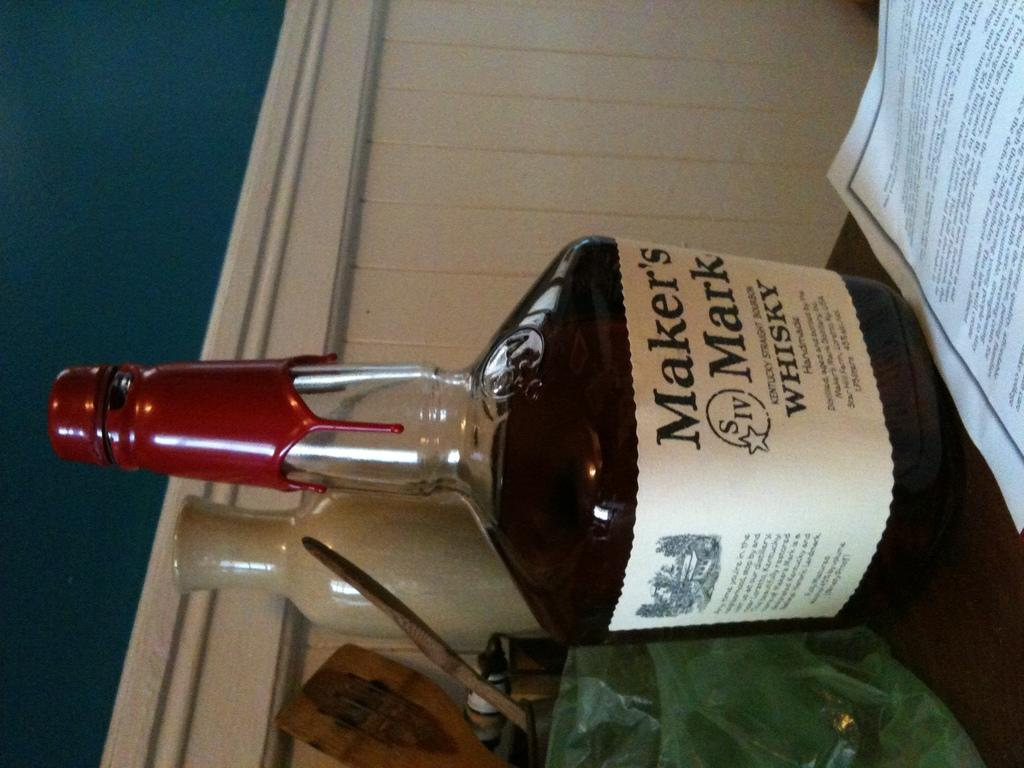Provide a one-sentence caption for the provided image. A bottle of Maker's Mark whiskey sits next to a piece of paper. 